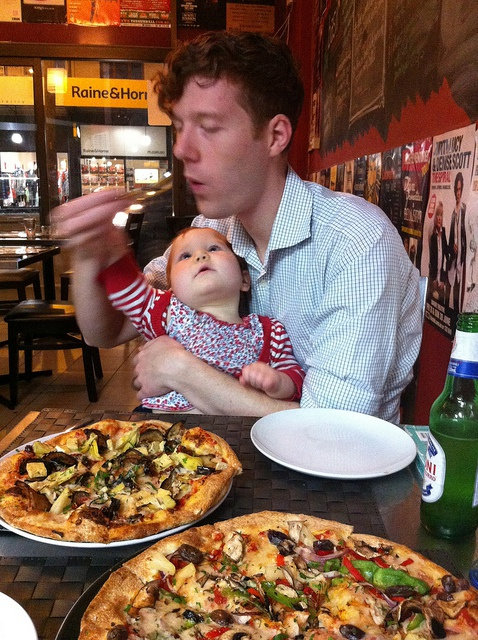Describe the objects in this image and their specific colors. I can see people in orange, brown, black, lightblue, and darkgray tones, pizza in orange, tan, brown, maroon, and olive tones, dining table in orange, black, maroon, and gray tones, pizza in orange, tan, brown, maroon, and black tones, and people in orange, lightpink, brown, darkgray, and maroon tones in this image. 